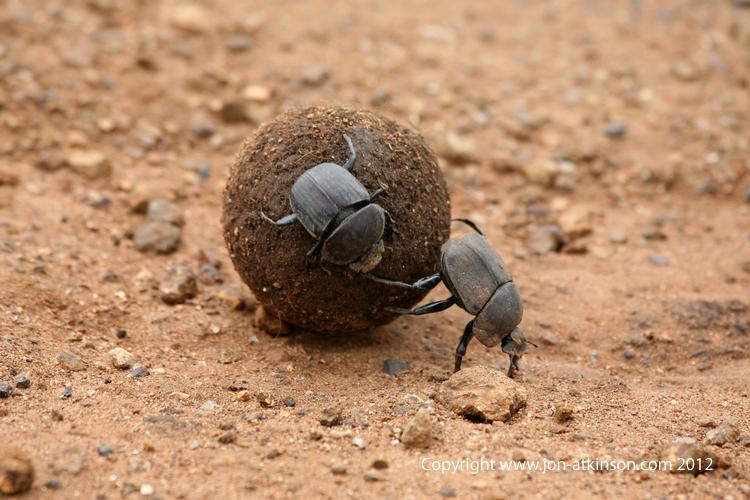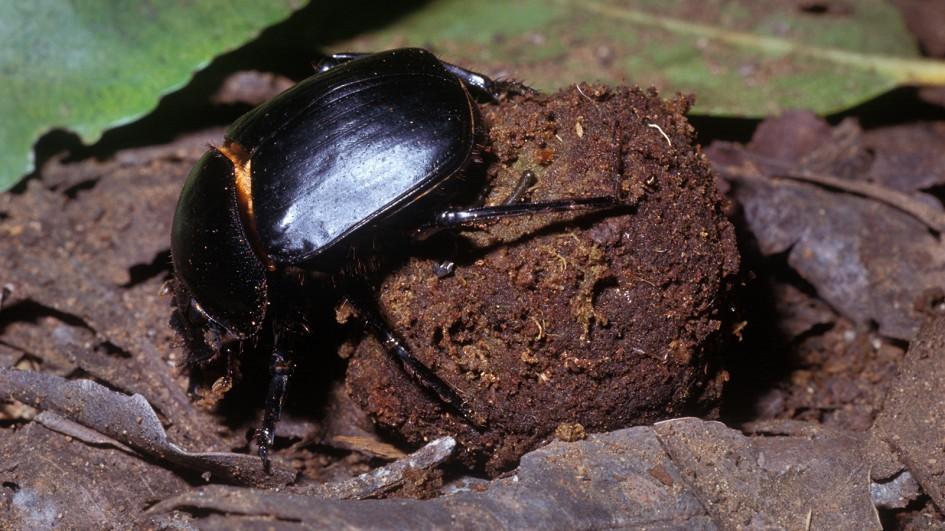The first image is the image on the left, the second image is the image on the right. For the images displayed, is the sentence "Each image has at least 2 dung beetles interacting with a piece of dung." factually correct? Answer yes or no. No. The first image is the image on the left, the second image is the image on the right. Considering the images on both sides, is "There are at most three beetles." valid? Answer yes or no. Yes. 